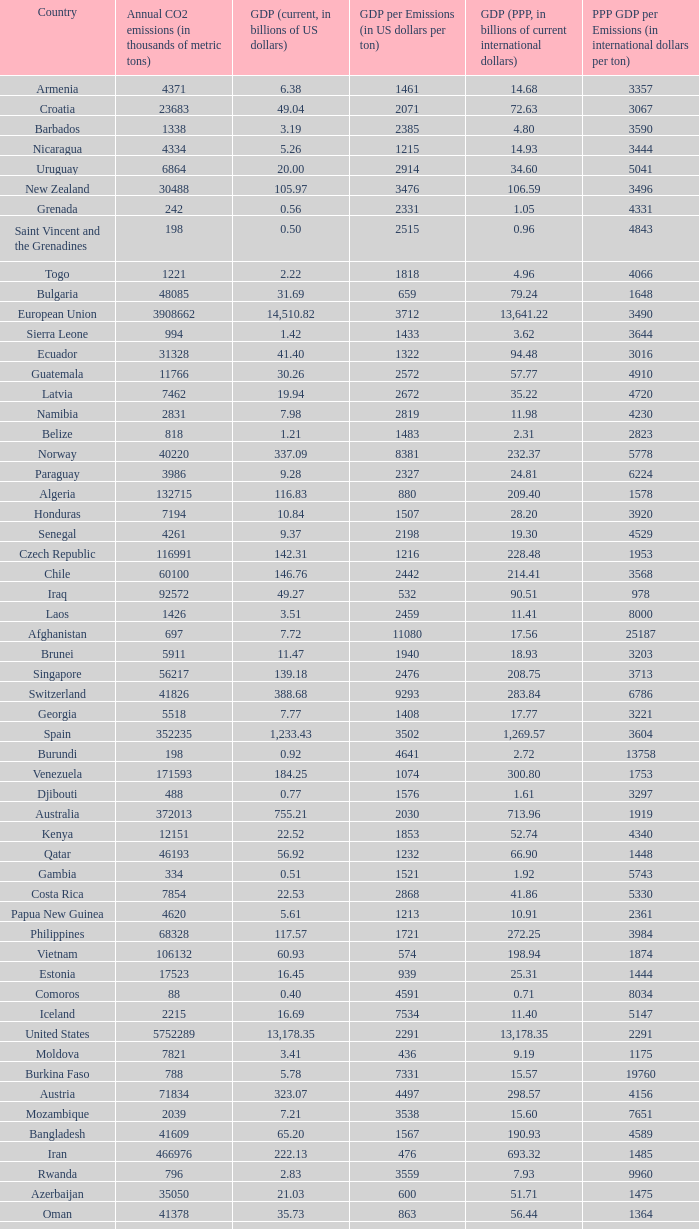When the gdp (current, in billions of us dollars) is 162.50, what is the gdp? 2562.0. 